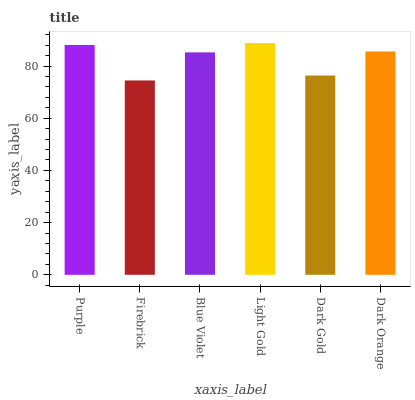Is Firebrick the minimum?
Answer yes or no. Yes. Is Light Gold the maximum?
Answer yes or no. Yes. Is Blue Violet the minimum?
Answer yes or no. No. Is Blue Violet the maximum?
Answer yes or no. No. Is Blue Violet greater than Firebrick?
Answer yes or no. Yes. Is Firebrick less than Blue Violet?
Answer yes or no. Yes. Is Firebrick greater than Blue Violet?
Answer yes or no. No. Is Blue Violet less than Firebrick?
Answer yes or no. No. Is Dark Orange the high median?
Answer yes or no. Yes. Is Blue Violet the low median?
Answer yes or no. Yes. Is Blue Violet the high median?
Answer yes or no. No. Is Purple the low median?
Answer yes or no. No. 